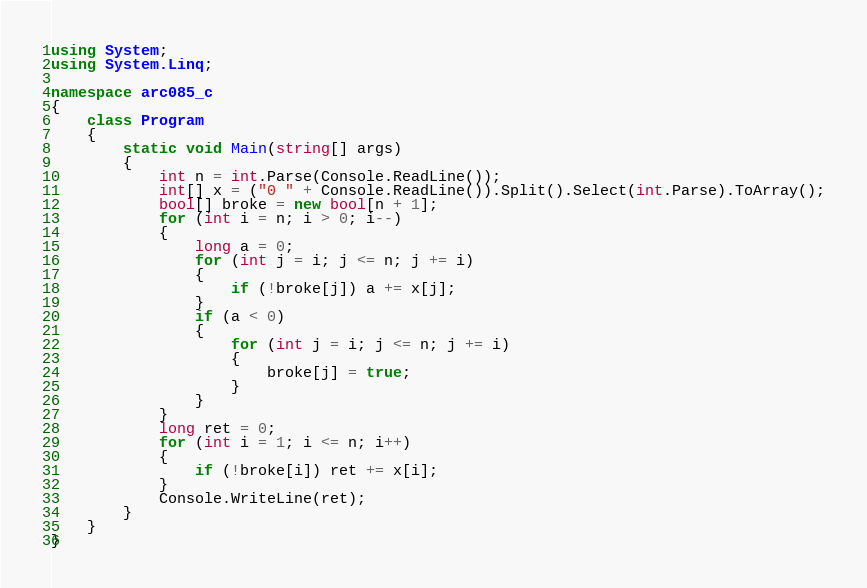<code> <loc_0><loc_0><loc_500><loc_500><_C#_>using System;
using System.Linq;

namespace arc085_c
{
    class Program
    {
        static void Main(string[] args)
        {
            int n = int.Parse(Console.ReadLine());
            int[] x = ("0 " + Console.ReadLine()).Split().Select(int.Parse).ToArray();
            bool[] broke = new bool[n + 1];
            for (int i = n; i > 0; i--)
            {
                long a = 0;
                for (int j = i; j <= n; j += i)
                {
                    if (!broke[j]) a += x[j];
                }
                if (a < 0)
                {
                    for (int j = i; j <= n; j += i)
                    {
                        broke[j] = true;
                    }
                }
            }
            long ret = 0;
            for (int i = 1; i <= n; i++)
            {
                if (!broke[i]) ret += x[i];
            }
            Console.WriteLine(ret);
        }
    }
}</code> 